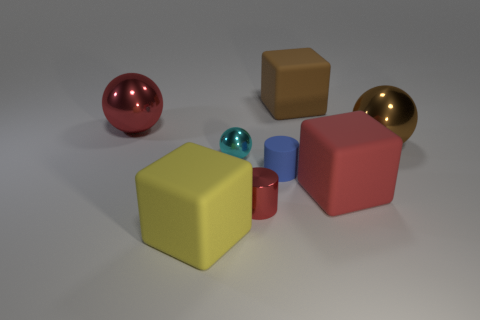Subtract all red cubes. How many cubes are left? 2 Subtract all cyan balls. How many balls are left? 2 Subtract all blocks. How many objects are left? 5 Subtract all cyan metallic objects. Subtract all small cyan metal balls. How many objects are left? 6 Add 1 large brown spheres. How many large brown spheres are left? 2 Add 8 large yellow matte things. How many large yellow matte things exist? 9 Add 2 spheres. How many objects exist? 10 Subtract 0 cyan cylinders. How many objects are left? 8 Subtract 2 spheres. How many spheres are left? 1 Subtract all blue blocks. Subtract all yellow spheres. How many blocks are left? 3 